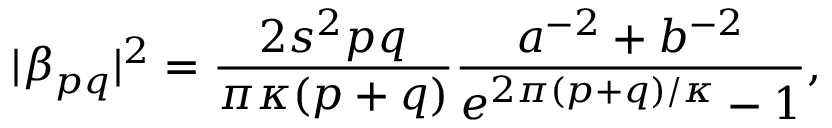Convert formula to latex. <formula><loc_0><loc_0><loc_500><loc_500>| \beta _ { p q } | ^ { 2 } = \frac { 2 s ^ { 2 } p q } { \pi \kappa ( p + q ) } \frac { a ^ { - 2 } + b ^ { - 2 } } { e ^ { 2 \pi ( p + q ) / \kappa } - 1 } ,</formula> 